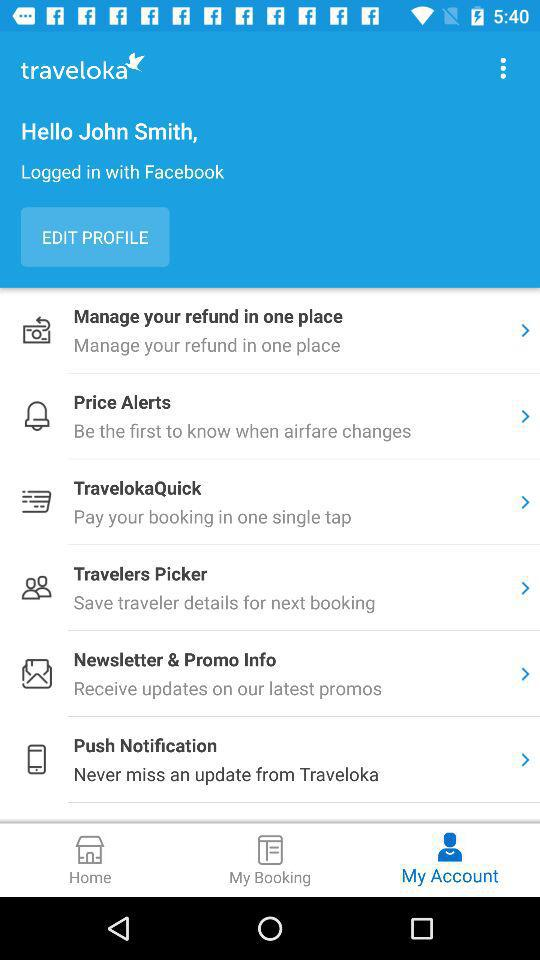What is the user name? The user name is John Smith. 